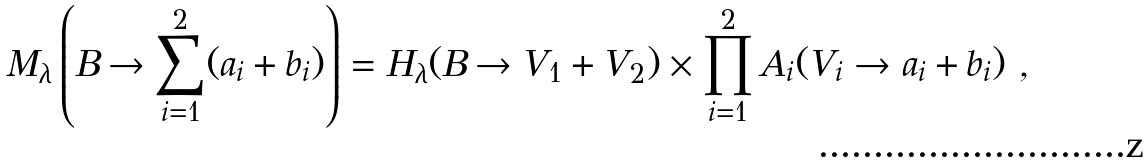<formula> <loc_0><loc_0><loc_500><loc_500>M _ { \lambda } \left ( B \rightarrow \sum _ { i = 1 } ^ { 2 } ( a _ { i } + b _ { i } ) \right ) = H _ { \lambda } ( B \rightarrow V _ { 1 } + V _ { 2 } ) \times \prod _ { i = 1 } ^ { 2 } A _ { i } ( V _ { i } \rightarrow a _ { i } + b _ { i } ) \ ,</formula> 